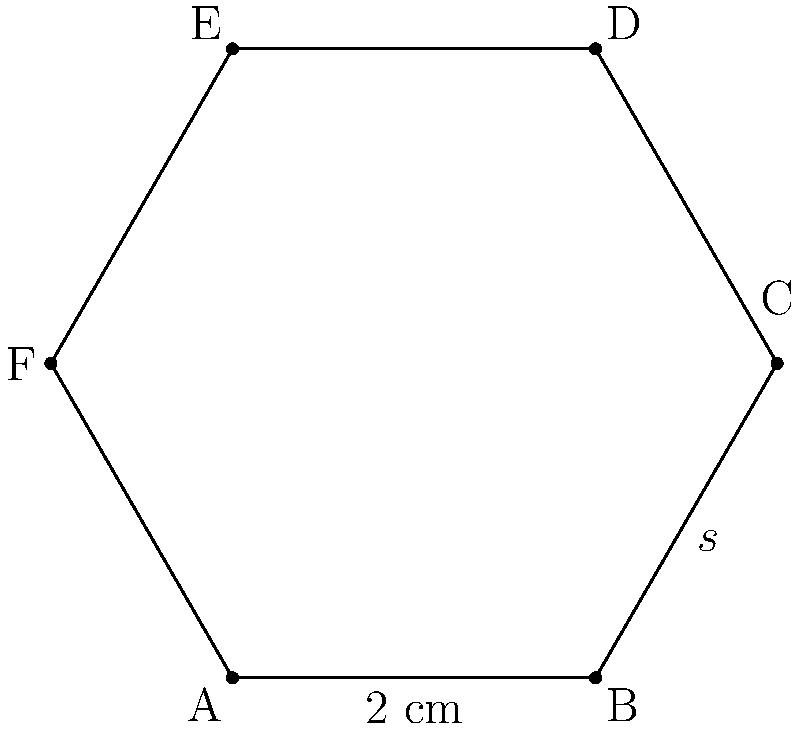As a pet sitter, you've noticed that the rescue dog's hexagonal food bowl needs to be replaced. To ensure you purchase the right size, you need to calculate the area of the current bowl. The hexagonal bowl has a side length of 2 cm. What is the area of the bowl's base in square centimeters? (Use $\sqrt{3} \approx 1.732$ for calculations) To find the area of a regular hexagon, we can use the formula:

$$A = \frac{3\sqrt{3}}{2}s^2$$

where $s$ is the side length of the hexagon.

Given:
- Side length $s = 2$ cm
- $\sqrt{3} \approx 1.732$

Steps:
1. Substitute the values into the formula:
   $$A = \frac{3\sqrt{3}}{2}(2)^2$$

2. Simplify:
   $$A = \frac{3\sqrt{3}}{2} \cdot 4$$
   $$A = 6\sqrt{3}$$

3. Approximate the result using $\sqrt{3} \approx 1.732$:
   $$A \approx 6 \cdot 1.732$$
   $$A \approx 10.392$$

4. Round to two decimal places:
   $$A \approx 10.39 \text{ cm}^2$$

Therefore, the area of the hexagonal food bowl's base is approximately 10.39 square centimeters.
Answer: $10.39 \text{ cm}^2$ 